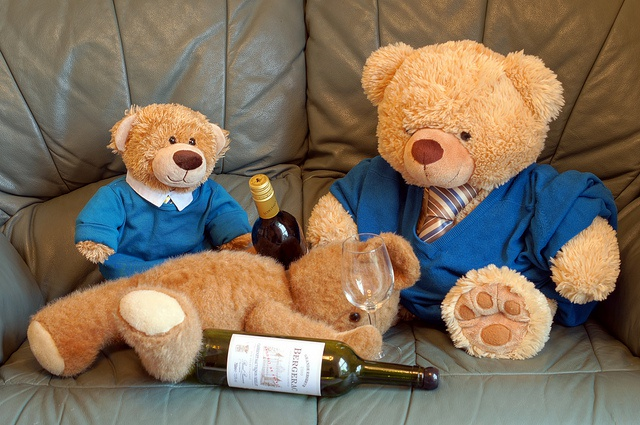Describe the objects in this image and their specific colors. I can see couch in gray, tan, maroon, and black tones, teddy bear in gray, tan, and blue tones, teddy bear in gray, tan, and red tones, teddy bear in gray, blue, and tan tones, and bottle in gray, white, black, olive, and maroon tones in this image. 